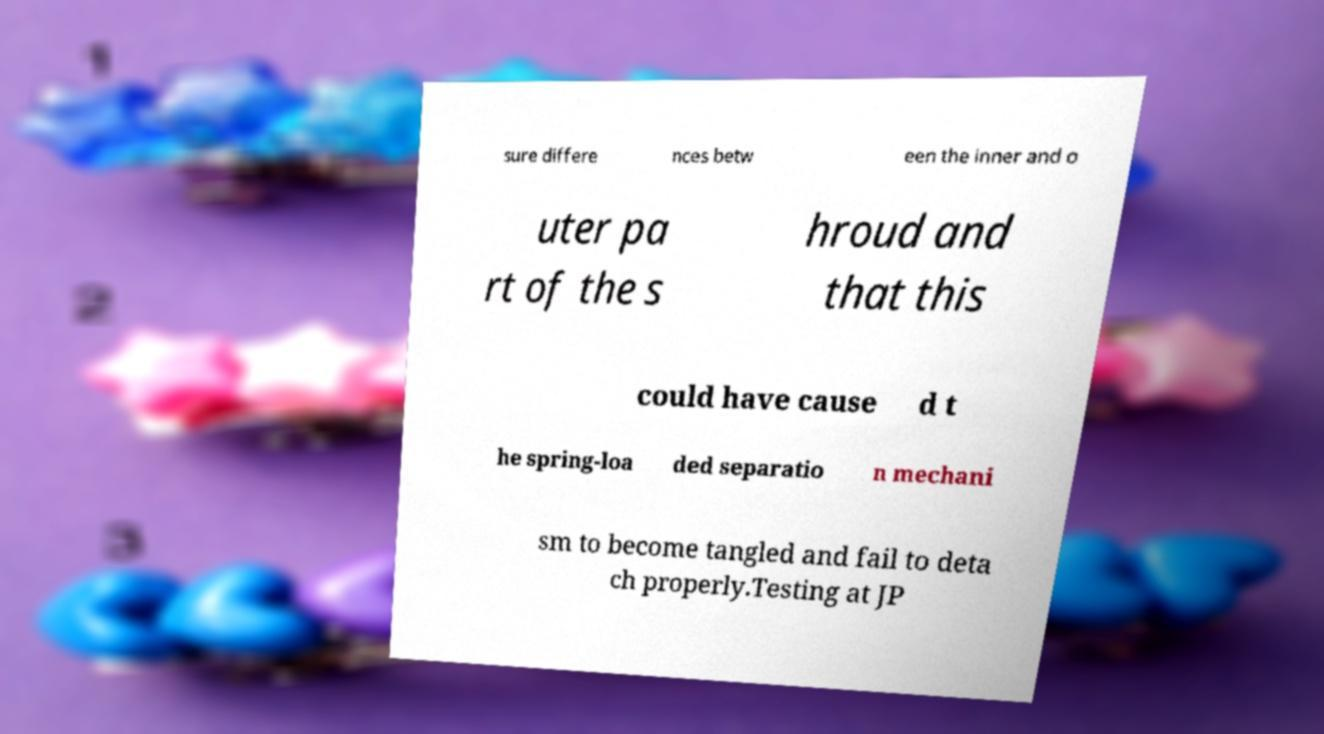I need the written content from this picture converted into text. Can you do that? sure differe nces betw een the inner and o uter pa rt of the s hroud and that this could have cause d t he spring-loa ded separatio n mechani sm to become tangled and fail to deta ch properly.Testing at JP 